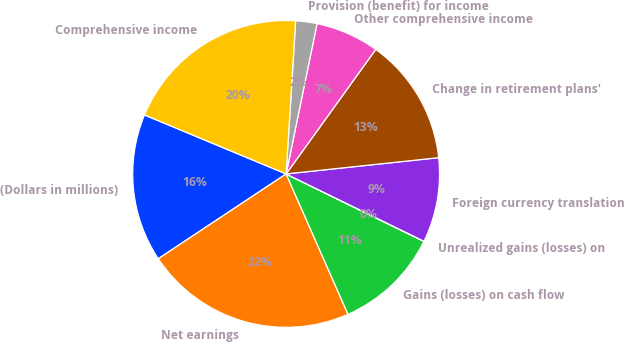<chart> <loc_0><loc_0><loc_500><loc_500><pie_chart><fcel>(Dollars in millions)<fcel>Net earnings<fcel>Gains (losses) on cash flow<fcel>Unrealized gains (losses) on<fcel>Foreign currency translation<fcel>Change in retirement plans'<fcel>Other comprehensive income<fcel>Provision (benefit) for income<fcel>Comprehensive income<nl><fcel>15.6%<fcel>22.29%<fcel>11.15%<fcel>0.01%<fcel>8.92%<fcel>13.38%<fcel>6.7%<fcel>2.24%<fcel>19.71%<nl></chart> 